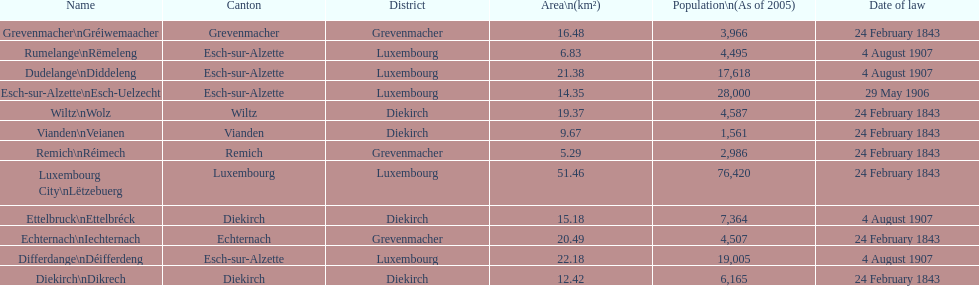How many luxembourg cities had a date of law of feb 24, 1843? 7. 